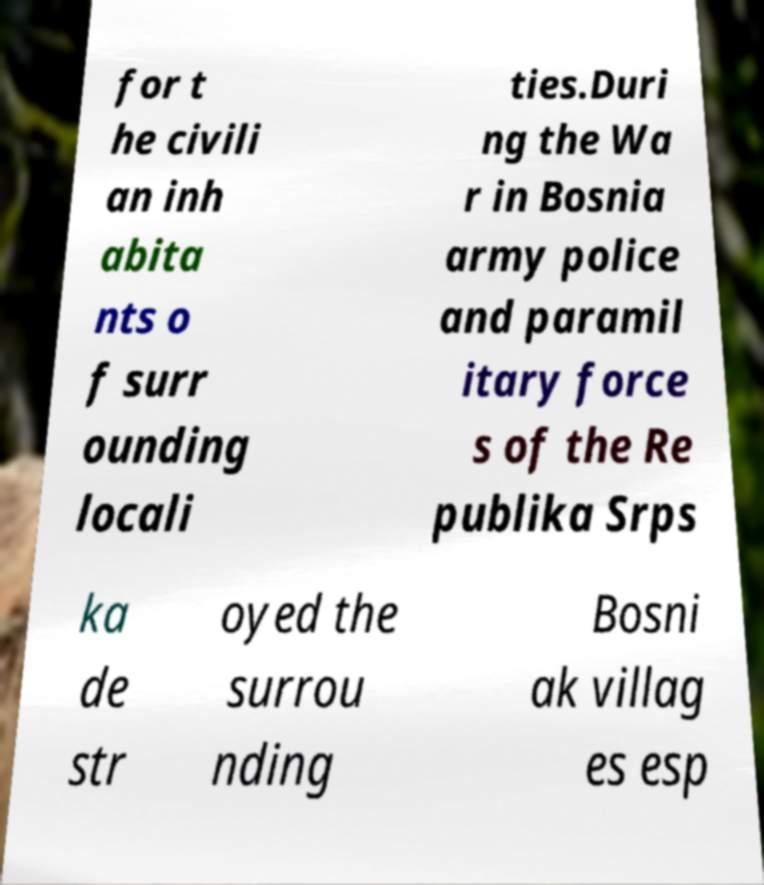What messages or text are displayed in this image? I need them in a readable, typed format. for t he civili an inh abita nts o f surr ounding locali ties.Duri ng the Wa r in Bosnia army police and paramil itary force s of the Re publika Srps ka de str oyed the surrou nding Bosni ak villag es esp 